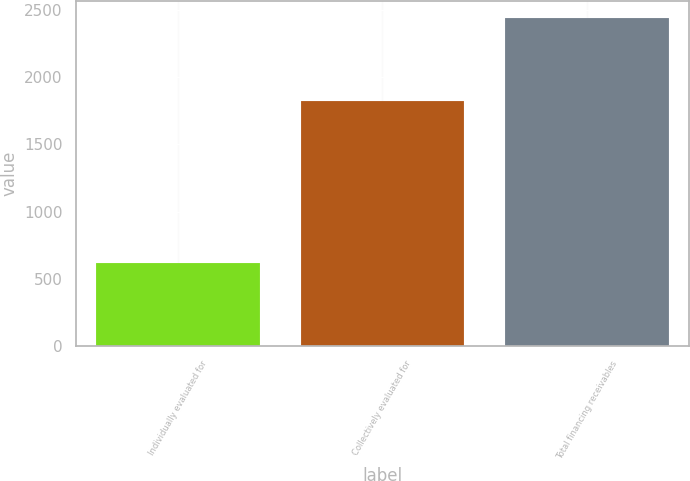Convert chart. <chart><loc_0><loc_0><loc_500><loc_500><bar_chart><fcel>Individually evaluated for<fcel>Collectively evaluated for<fcel>Total financing receivables<nl><fcel>616<fcel>1826<fcel>2442<nl></chart> 